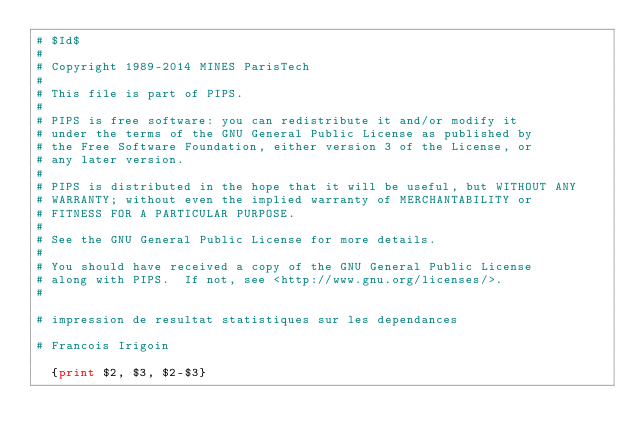<code> <loc_0><loc_0><loc_500><loc_500><_Awk_># $Id$
#
# Copyright 1989-2014 MINES ParisTech
#
# This file is part of PIPS.
#
# PIPS is free software: you can redistribute it and/or modify it
# under the terms of the GNU General Public License as published by
# the Free Software Foundation, either version 3 of the License, or
# any later version.
#
# PIPS is distributed in the hope that it will be useful, but WITHOUT ANY
# WARRANTY; without even the implied warranty of MERCHANTABILITY or
# FITNESS FOR A PARTICULAR PURPOSE.
#
# See the GNU General Public License for more details.
#
# You should have received a copy of the GNU General Public License
# along with PIPS.  If not, see <http://www.gnu.org/licenses/>.
#

# impression de resultat statistiques sur les dependances

# Francois Irigoin

	{print $2, $3, $2-$3}
</code> 